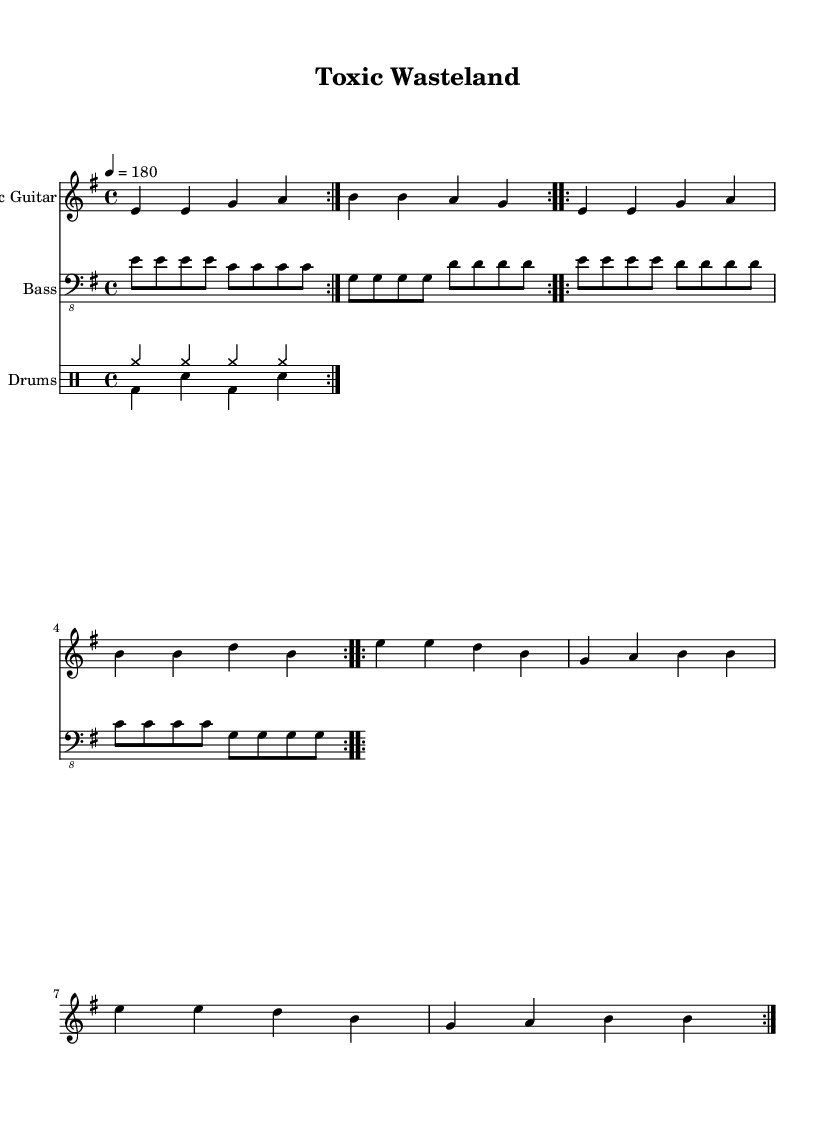What is the key signature of this music? The key signature is indicated at the beginning of the music sheet, showing two sharps. In this case, the key signature corresponds to E minor.
Answer: E minor What is the time signature of the piece? The time signature is found at the beginning of the sheet music and is indicated by the "4/4" notation. This indicates that there are four beats in each measure and a quarter note gets one beat.
Answer: 4/4 What is the tempo marked in the music? The tempo is specified near the beginning of the music as "4 = 180," which indicates that there should be 180 quarter note beats per minute.
Answer: 180 How many volta repeats are there in the electric guitar part? The sheet music contains the "repeat volta 2" markings for the electric guitar part. This indicates that the section is meant to be repeated twice.
Answer: 2 What type of drum pattern is used for the drums up? The drum part indicates "cymr" notation across measures, which refers to cymbal crashes being played consistently. This pattern is a characteristic element in punk music.
Answer: Cymbal crashes How does the bass guitar rhythm differ from the electric guitar? By comparing the parts, the bass guitar rhythm employs eighth notes, emphasizing a consistent, steady beat with a contrasting pattern to the quarter notes in the electric guitar, adding to the song's energetic feel.
Answer: Eighth notes What environmental theme is addressed in this piece? The title "Toxic Wasteland" suggests a focus on issues such as chemical pollution and environmental degradation. The naming conveys a strong message, which is common in punk music that addresses societal issues.
Answer: Chemical pollution 